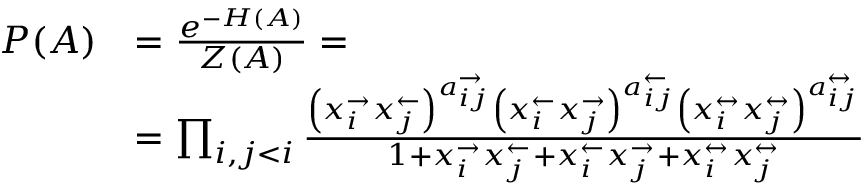Convert formula to latex. <formula><loc_0><loc_0><loc_500><loc_500>\begin{array} { r l } { P ( A ) } & { = \frac { e ^ { - H ( A ) } } { Z ( A ) } = } \\ & { = \prod _ { i , j < i } \frac { \left ( x _ { i } ^ { \rightarrow } x _ { j } ^ { \leftarrow } \right ) ^ { a _ { i j } ^ { \rightarrow } } \left ( x _ { i } ^ { \leftarrow } x _ { j } ^ { \rightarrow } \right ) ^ { a _ { i j } ^ { \leftarrow } } \left ( x _ { i } ^ { \leftrightarrow } x _ { j } ^ { \leftrightarrow } \right ) ^ { a _ { i j } ^ { \leftrightarrow } } } { 1 + x _ { i } ^ { \rightarrow } x _ { j } ^ { \leftarrow } + x _ { i } ^ { \leftarrow } x _ { j } ^ { \rightarrow } + x _ { i } ^ { \leftrightarrow } x _ { j } ^ { \leftrightarrow } } } \end{array}</formula> 